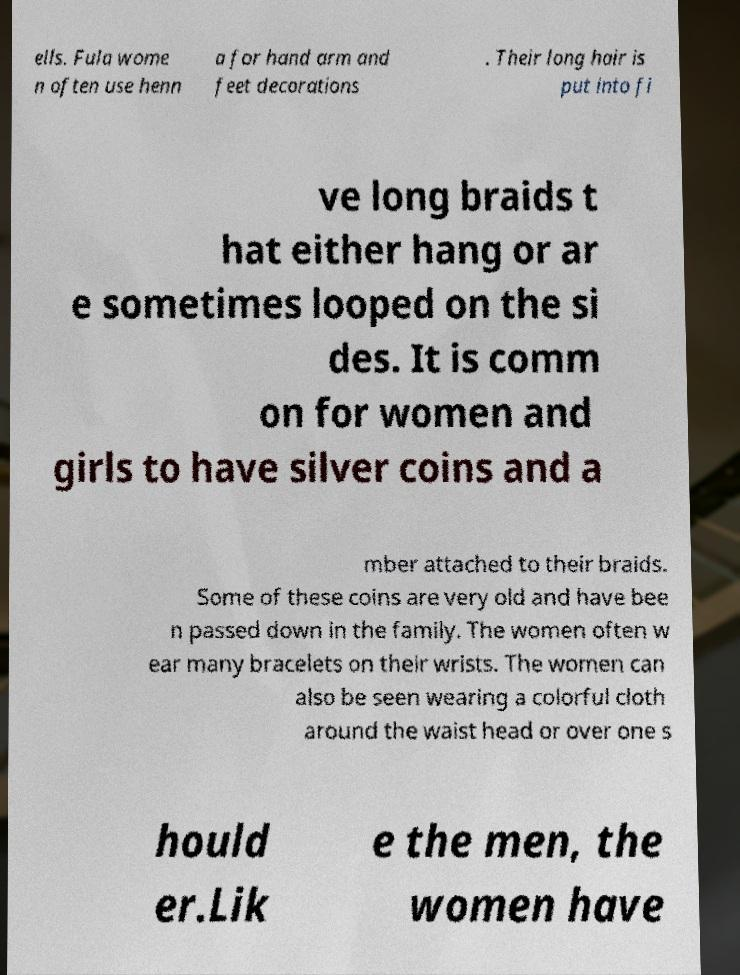Can you read and provide the text displayed in the image?This photo seems to have some interesting text. Can you extract and type it out for me? ells. Fula wome n often use henn a for hand arm and feet decorations . Their long hair is put into fi ve long braids t hat either hang or ar e sometimes looped on the si des. It is comm on for women and girls to have silver coins and a mber attached to their braids. Some of these coins are very old and have bee n passed down in the family. The women often w ear many bracelets on their wrists. The women can also be seen wearing a colorful cloth around the waist head or over one s hould er.Lik e the men, the women have 